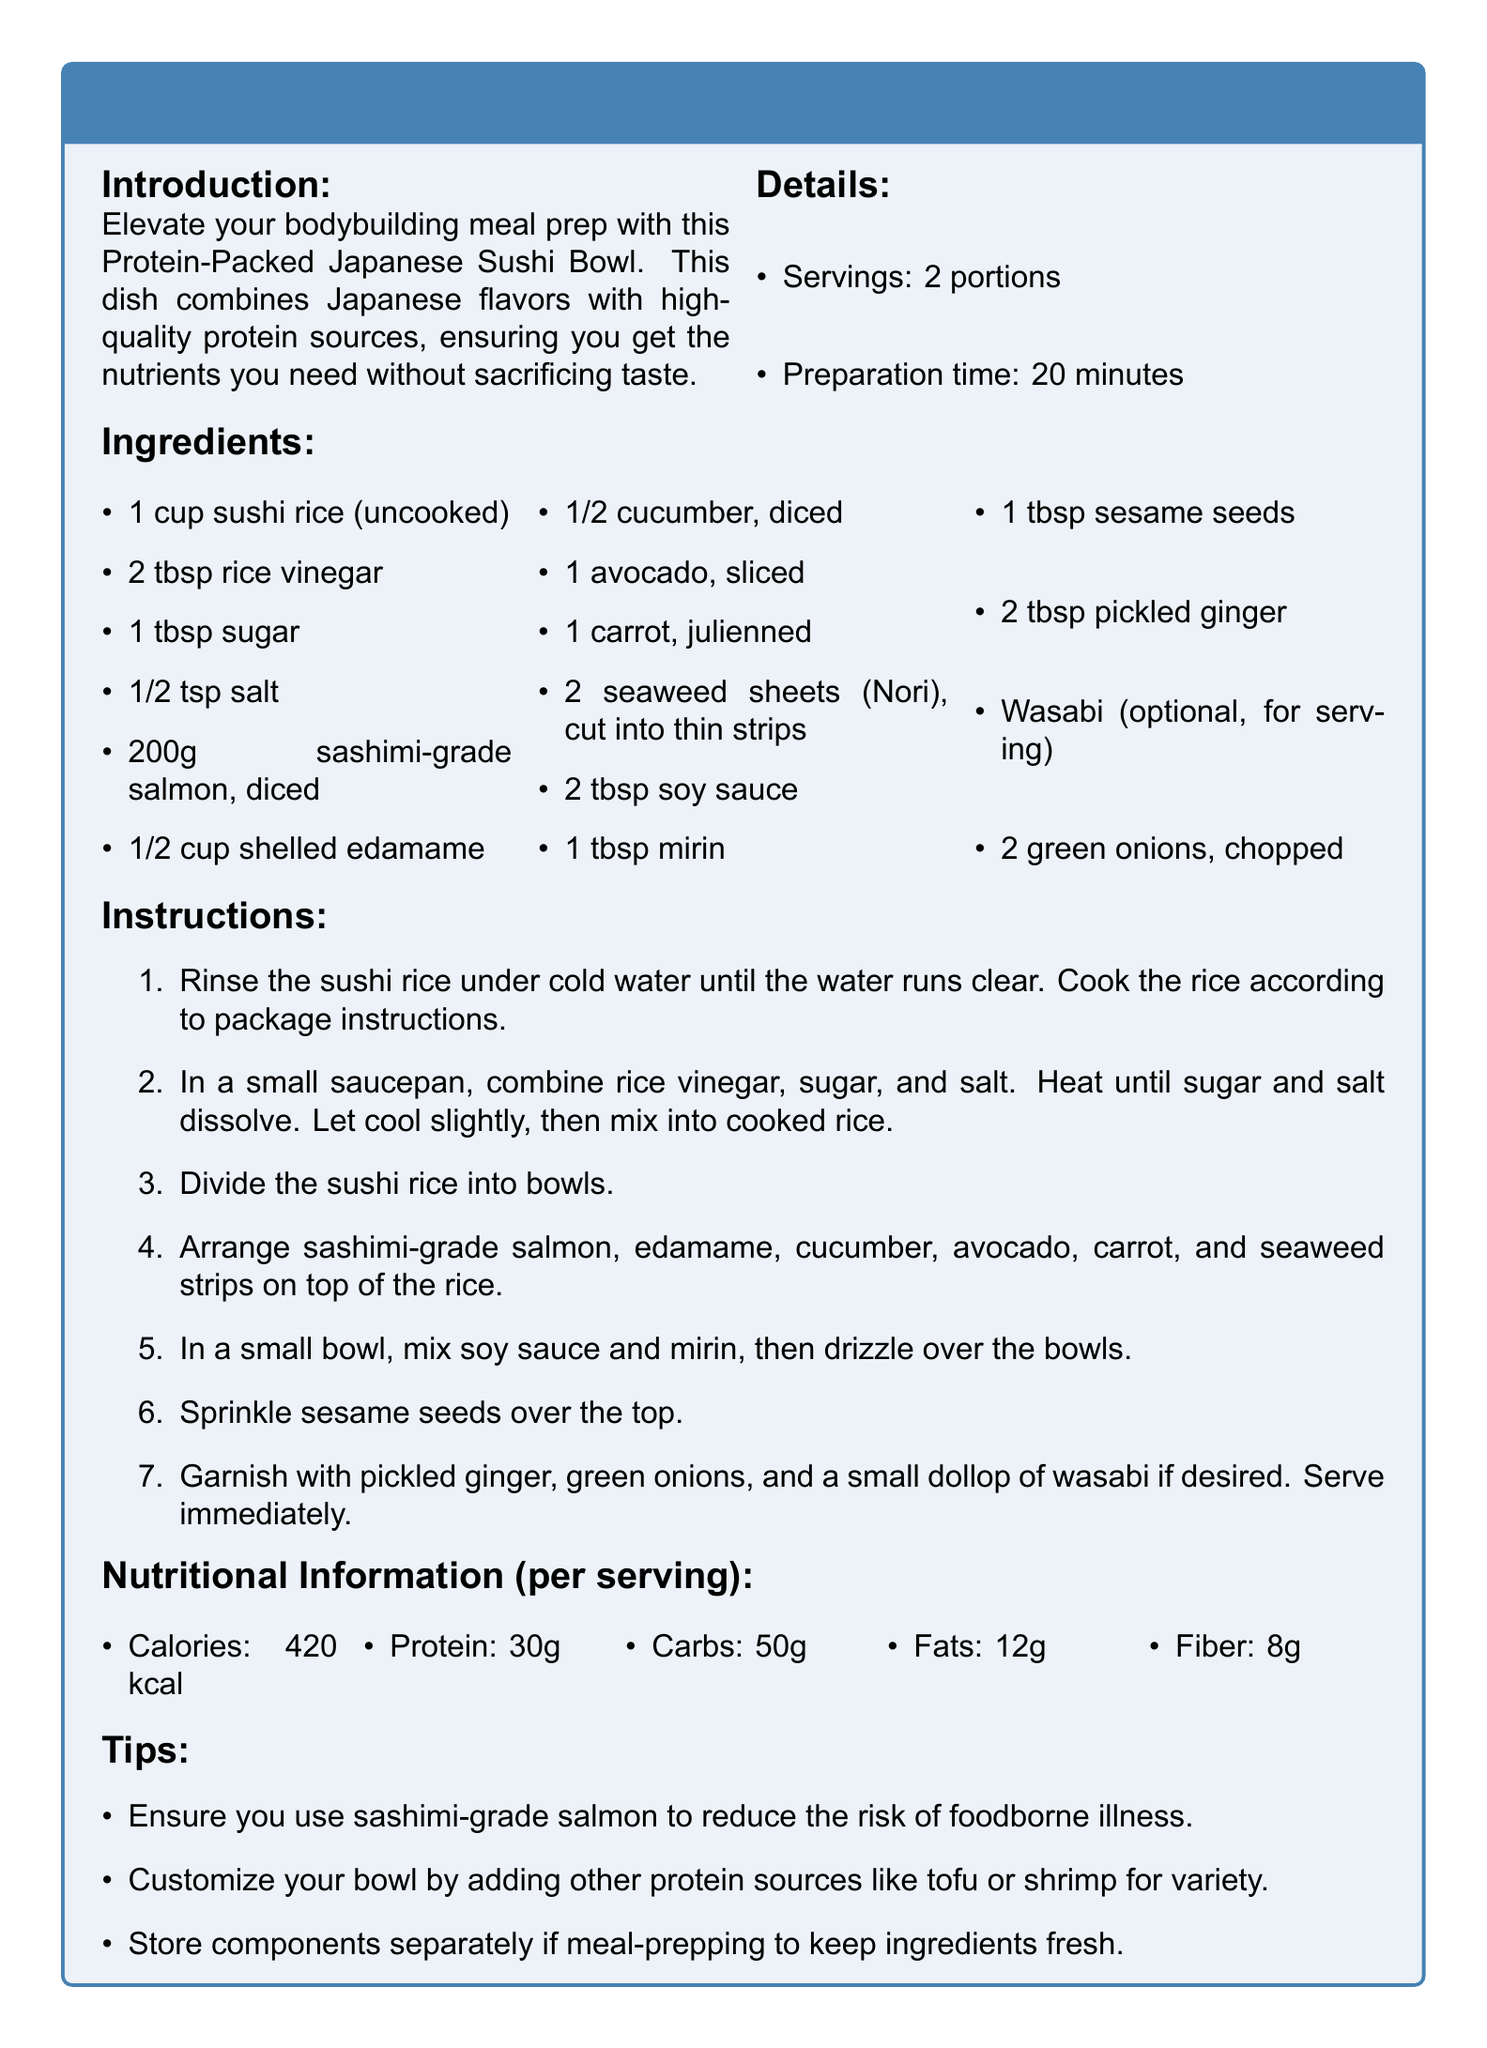what is the serving size? The serving size is indicated in the details section of the document, which mentions "2 portions."
Answer: 2 portions how long does it take to prepare? The preparation time is stated in the details section of the document, which is "20 minutes."
Answer: 20 minutes how many calories does one serving have? The nutritional information section specifies "Calories: 420 kcal" for one serving.
Answer: 420 kcal what protein source is used in this recipe? The ingredients list includes "sashimi-grade salmon," which serves as the primary protein source.
Answer: sashimi-grade salmon what ingredient is used to season the sushi rice? The instructions mention combining "rice vinegar, sugar, and salt" to season the sushi rice.
Answer: rice vinegar which vegetable is sliced for garnish? The ingredients section includes "1 avocado, sliced," indicating it is used for garnish.
Answer: avocado what is one tip provided in the document? The tips section suggests "Ensure you use sashimi-grade salmon to reduce the risk of foodborne illness."
Answer: Use sashimi-grade salmon how many grams of protein are in one serving? The nutritional information specifies that there are "30g" of protein per serving.
Answer: 30g what optional condiment is suggested for serving? The document mentions "Wasabi (optional, for serving)" indicating it is not necessary but suggested.
Answer: Wasabi 